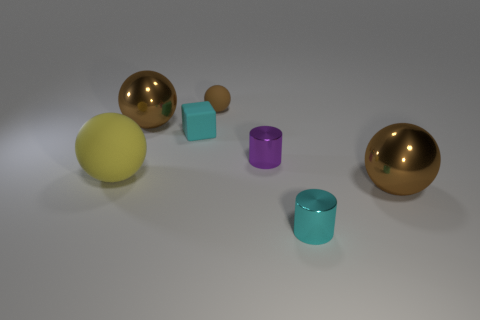Subtract all big yellow rubber spheres. How many spheres are left? 3 Subtract all red blocks. How many brown balls are left? 3 Add 1 tiny matte cubes. How many objects exist? 8 Subtract all yellow spheres. How many spheres are left? 3 Subtract all gray blocks. Subtract all brown balls. How many blocks are left? 1 Subtract all small matte spheres. Subtract all small cyan rubber cubes. How many objects are left? 5 Add 5 tiny balls. How many tiny balls are left? 6 Add 1 purple metal cylinders. How many purple metal cylinders exist? 2 Subtract 0 green blocks. How many objects are left? 7 Subtract all cylinders. How many objects are left? 5 